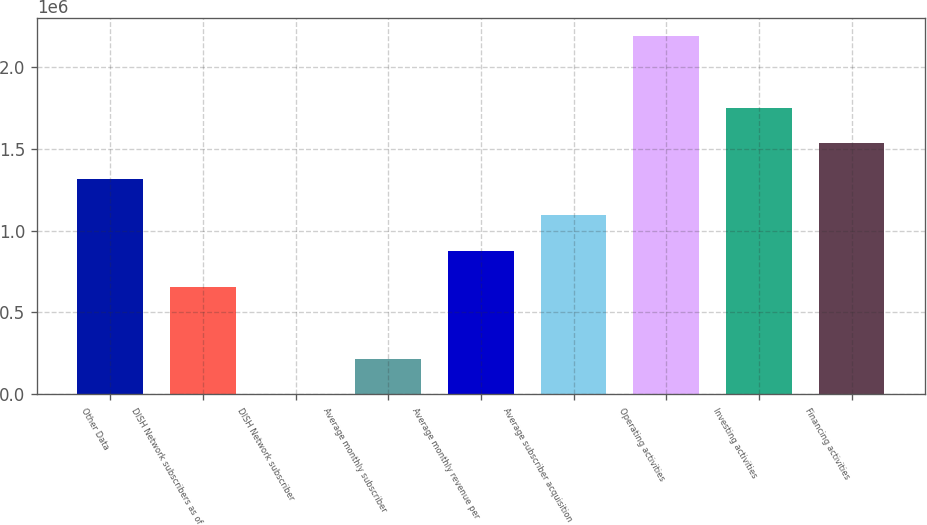Convert chart. <chart><loc_0><loc_0><loc_500><loc_500><bar_chart><fcel>Other Data<fcel>DISH Network subscribers as of<fcel>DISH Network subscriber<fcel>Average monthly subscriber<fcel>Average monthly revenue per<fcel>Average subscriber acquisition<fcel>Operating activities<fcel>Investing activities<fcel>Financing activities<nl><fcel>1.31301e+06<fcel>656503<fcel>0.1<fcel>218834<fcel>875338<fcel>1.09417e+06<fcel>2.18834e+06<fcel>1.75068e+06<fcel>1.53184e+06<nl></chart> 